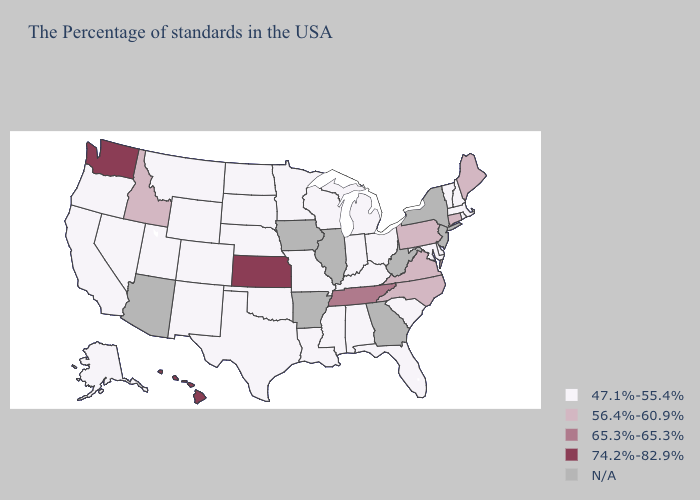Which states hav the highest value in the South?
Concise answer only. Tennessee. Does Virginia have the lowest value in the USA?
Keep it brief. No. What is the highest value in the USA?
Write a very short answer. 74.2%-82.9%. Does Kentucky have the highest value in the USA?
Concise answer only. No. What is the value of Massachusetts?
Be succinct. 47.1%-55.4%. Does Michigan have the lowest value in the MidWest?
Short answer required. Yes. Does the first symbol in the legend represent the smallest category?
Concise answer only. Yes. What is the value of Washington?
Quick response, please. 74.2%-82.9%. Which states have the highest value in the USA?
Quick response, please. Kansas, Washington, Hawaii. Does Alabama have the lowest value in the USA?
Give a very brief answer. Yes. Name the states that have a value in the range 65.3%-65.3%?
Give a very brief answer. Tennessee. What is the highest value in the MidWest ?
Write a very short answer. 74.2%-82.9%. Does the map have missing data?
Short answer required. Yes. How many symbols are there in the legend?
Be succinct. 5. Name the states that have a value in the range 65.3%-65.3%?
Concise answer only. Tennessee. 